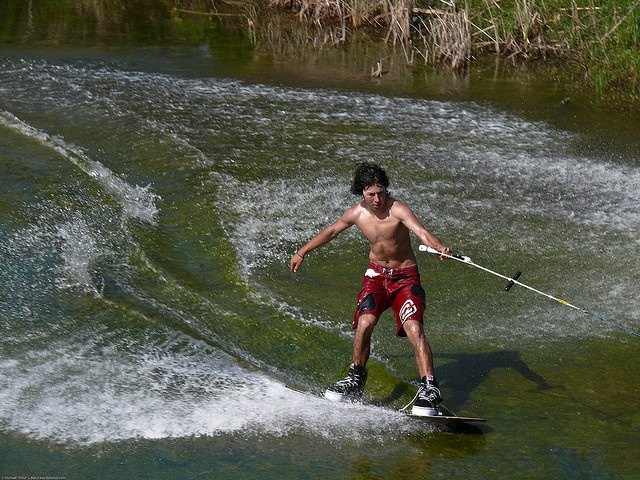Describe the objects in this image and their specific colors. I can see people in black, maroon, brown, and gray tones and surfboard in black, lightgray, darkgray, and gray tones in this image. 